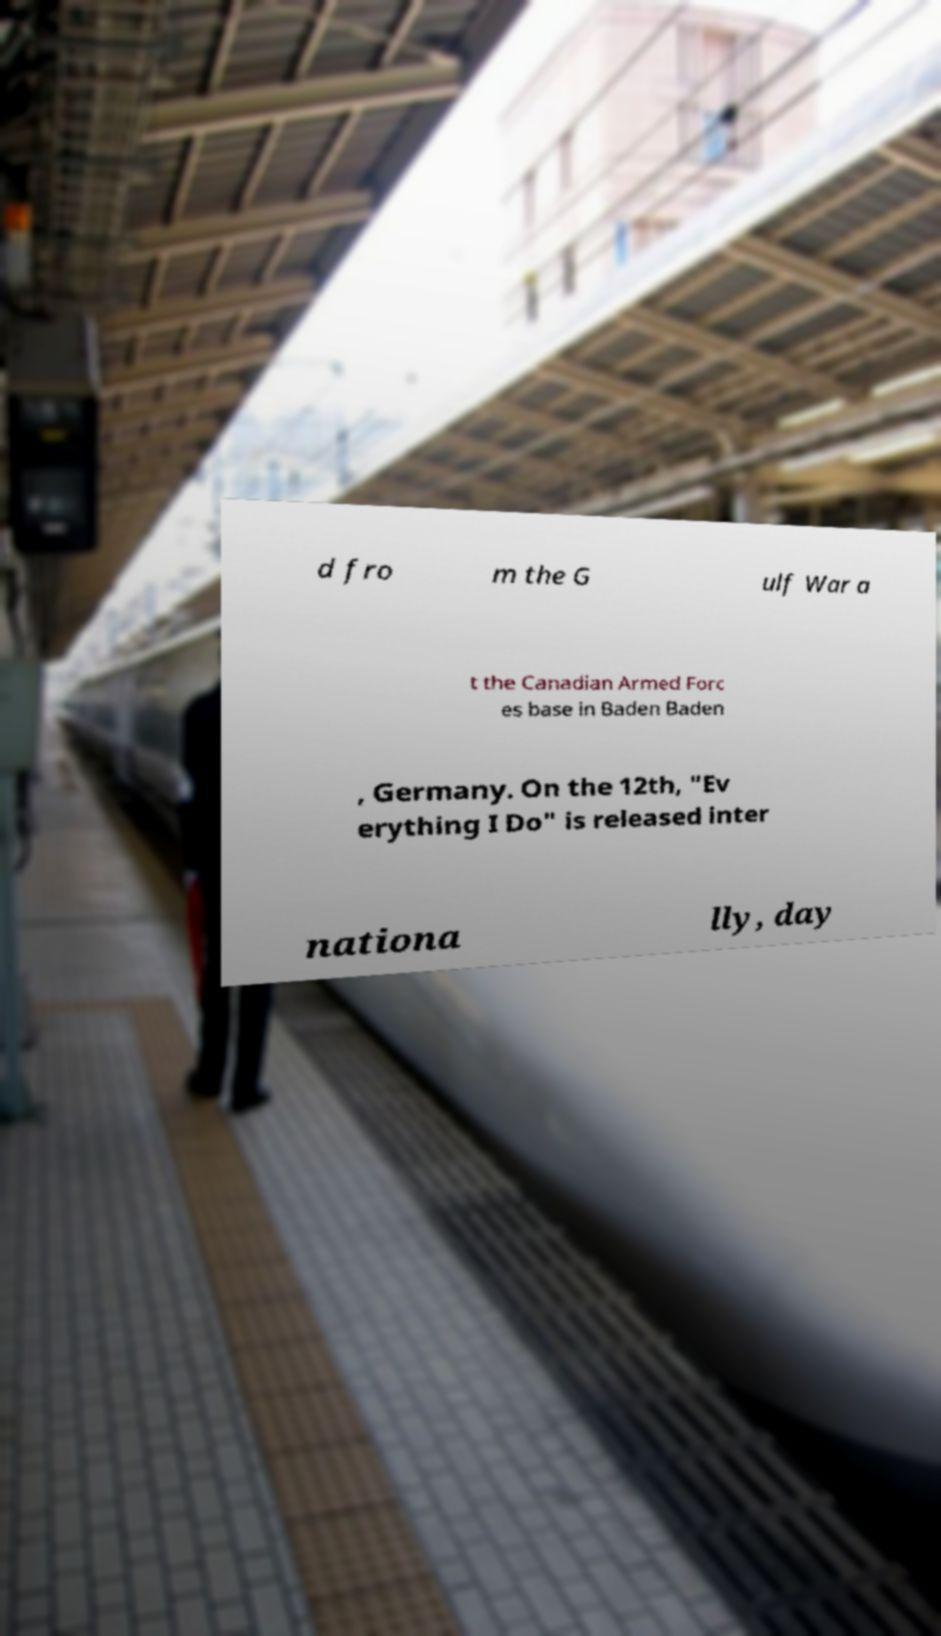What messages or text are displayed in this image? I need them in a readable, typed format. d fro m the G ulf War a t the Canadian Armed Forc es base in Baden Baden , Germany. On the 12th, "Ev erything I Do" is released inter nationa lly, day 